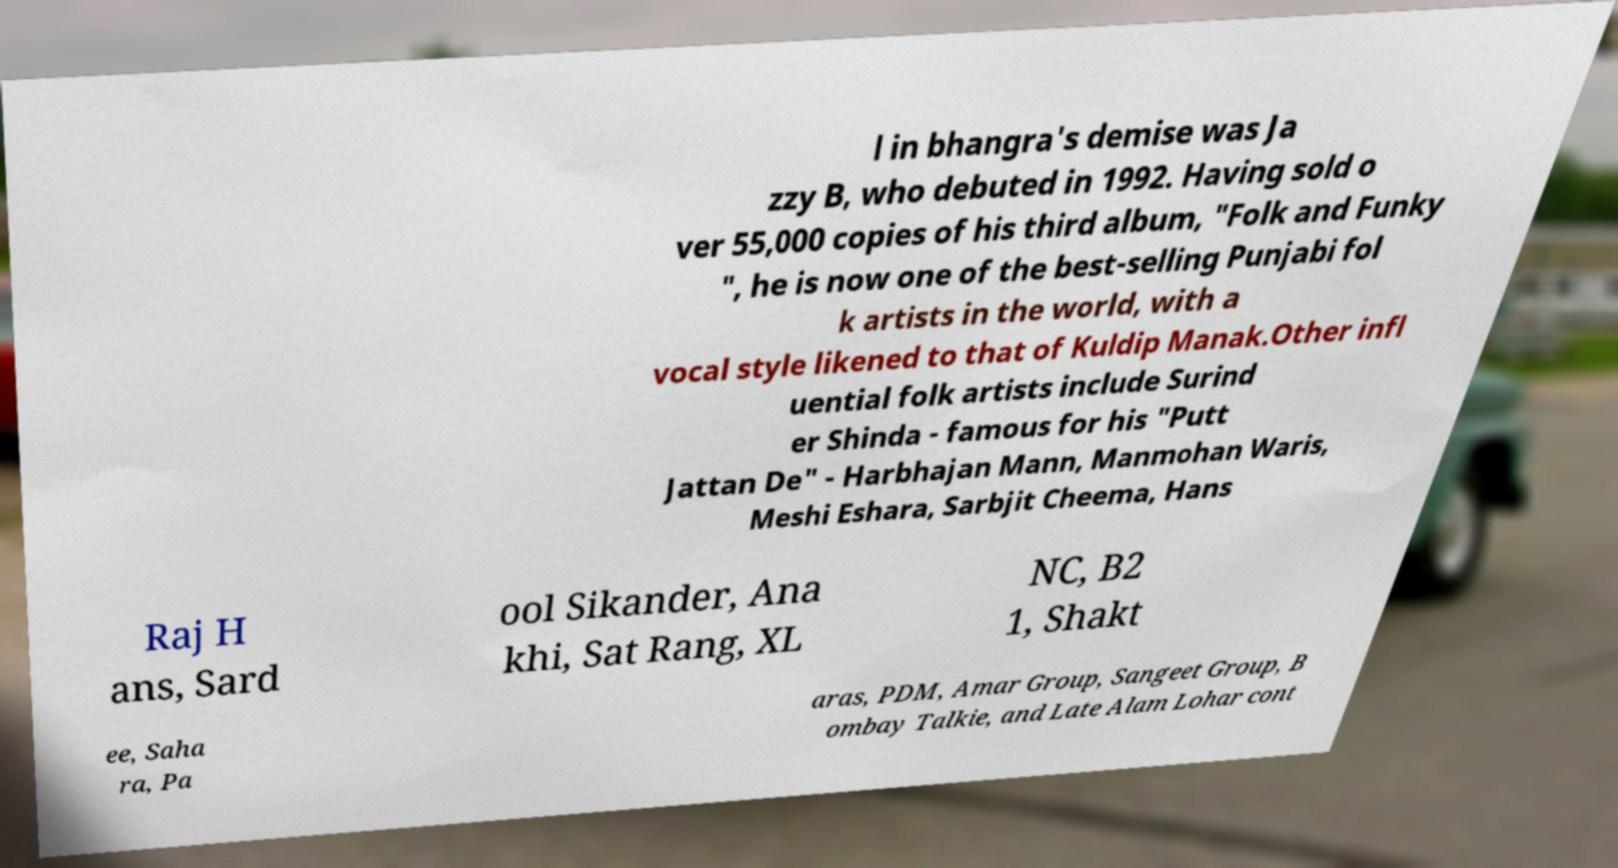Could you assist in decoding the text presented in this image and type it out clearly? l in bhangra's demise was Ja zzy B, who debuted in 1992. Having sold o ver 55,000 copies of his third album, "Folk and Funky ", he is now one of the best-selling Punjabi fol k artists in the world, with a vocal style likened to that of Kuldip Manak.Other infl uential folk artists include Surind er Shinda - famous for his "Putt Jattan De" - Harbhajan Mann, Manmohan Waris, Meshi Eshara, Sarbjit Cheema, Hans Raj H ans, Sard ool Sikander, Ana khi, Sat Rang, XL NC, B2 1, Shakt ee, Saha ra, Pa aras, PDM, Amar Group, Sangeet Group, B ombay Talkie, and Late Alam Lohar cont 